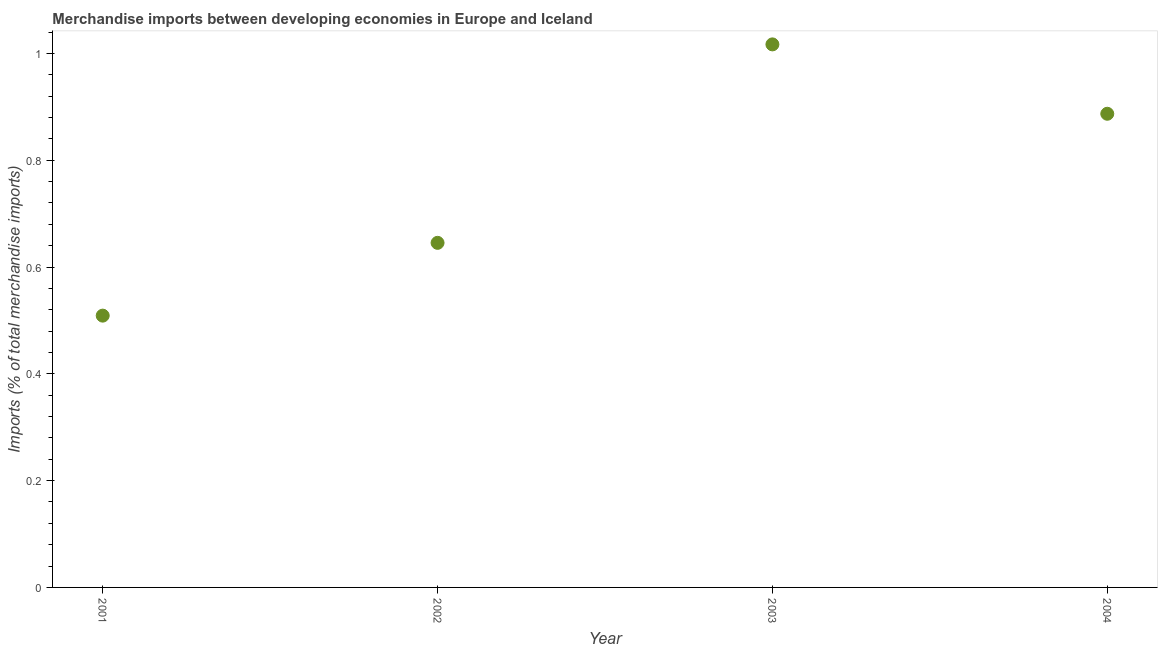What is the merchandise imports in 2001?
Your answer should be compact. 0.51. Across all years, what is the maximum merchandise imports?
Offer a very short reply. 1.02. Across all years, what is the minimum merchandise imports?
Offer a terse response. 0.51. What is the sum of the merchandise imports?
Ensure brevity in your answer.  3.06. What is the difference between the merchandise imports in 2001 and 2003?
Your answer should be compact. -0.51. What is the average merchandise imports per year?
Keep it short and to the point. 0.76. What is the median merchandise imports?
Make the answer very short. 0.77. Do a majority of the years between 2001 and 2003 (inclusive) have merchandise imports greater than 0.28 %?
Your answer should be very brief. Yes. What is the ratio of the merchandise imports in 2001 to that in 2002?
Your answer should be compact. 0.79. Is the merchandise imports in 2001 less than that in 2003?
Give a very brief answer. Yes. What is the difference between the highest and the second highest merchandise imports?
Provide a short and direct response. 0.13. What is the difference between the highest and the lowest merchandise imports?
Ensure brevity in your answer.  0.51. How many dotlines are there?
Provide a succinct answer. 1. How many years are there in the graph?
Your answer should be very brief. 4. Does the graph contain any zero values?
Keep it short and to the point. No. Does the graph contain grids?
Provide a succinct answer. No. What is the title of the graph?
Your response must be concise. Merchandise imports between developing economies in Europe and Iceland. What is the label or title of the Y-axis?
Keep it short and to the point. Imports (% of total merchandise imports). What is the Imports (% of total merchandise imports) in 2001?
Ensure brevity in your answer.  0.51. What is the Imports (% of total merchandise imports) in 2002?
Provide a short and direct response. 0.65. What is the Imports (% of total merchandise imports) in 2003?
Keep it short and to the point. 1.02. What is the Imports (% of total merchandise imports) in 2004?
Your response must be concise. 0.89. What is the difference between the Imports (% of total merchandise imports) in 2001 and 2002?
Your response must be concise. -0.14. What is the difference between the Imports (% of total merchandise imports) in 2001 and 2003?
Offer a terse response. -0.51. What is the difference between the Imports (% of total merchandise imports) in 2001 and 2004?
Ensure brevity in your answer.  -0.38. What is the difference between the Imports (% of total merchandise imports) in 2002 and 2003?
Make the answer very short. -0.37. What is the difference between the Imports (% of total merchandise imports) in 2002 and 2004?
Your answer should be compact. -0.24. What is the difference between the Imports (% of total merchandise imports) in 2003 and 2004?
Make the answer very short. 0.13. What is the ratio of the Imports (% of total merchandise imports) in 2001 to that in 2002?
Provide a short and direct response. 0.79. What is the ratio of the Imports (% of total merchandise imports) in 2001 to that in 2004?
Your answer should be very brief. 0.57. What is the ratio of the Imports (% of total merchandise imports) in 2002 to that in 2003?
Your answer should be compact. 0.64. What is the ratio of the Imports (% of total merchandise imports) in 2002 to that in 2004?
Provide a short and direct response. 0.73. What is the ratio of the Imports (% of total merchandise imports) in 2003 to that in 2004?
Ensure brevity in your answer.  1.15. 